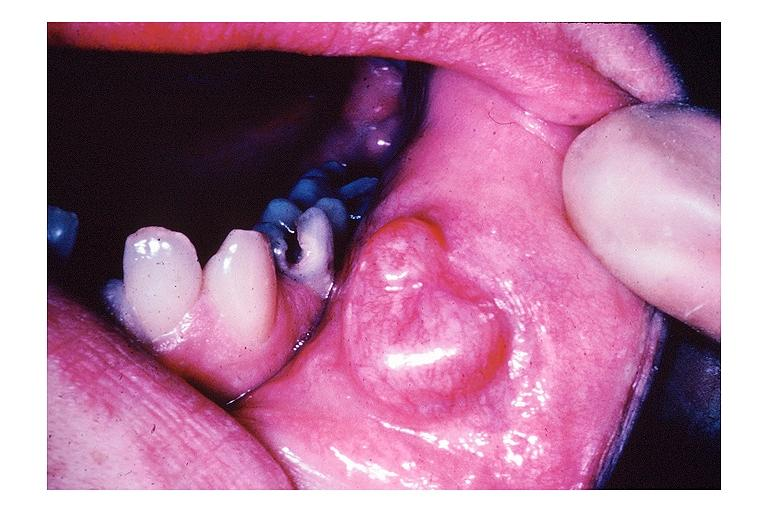s oral present?
Answer the question using a single word or phrase. Yes 